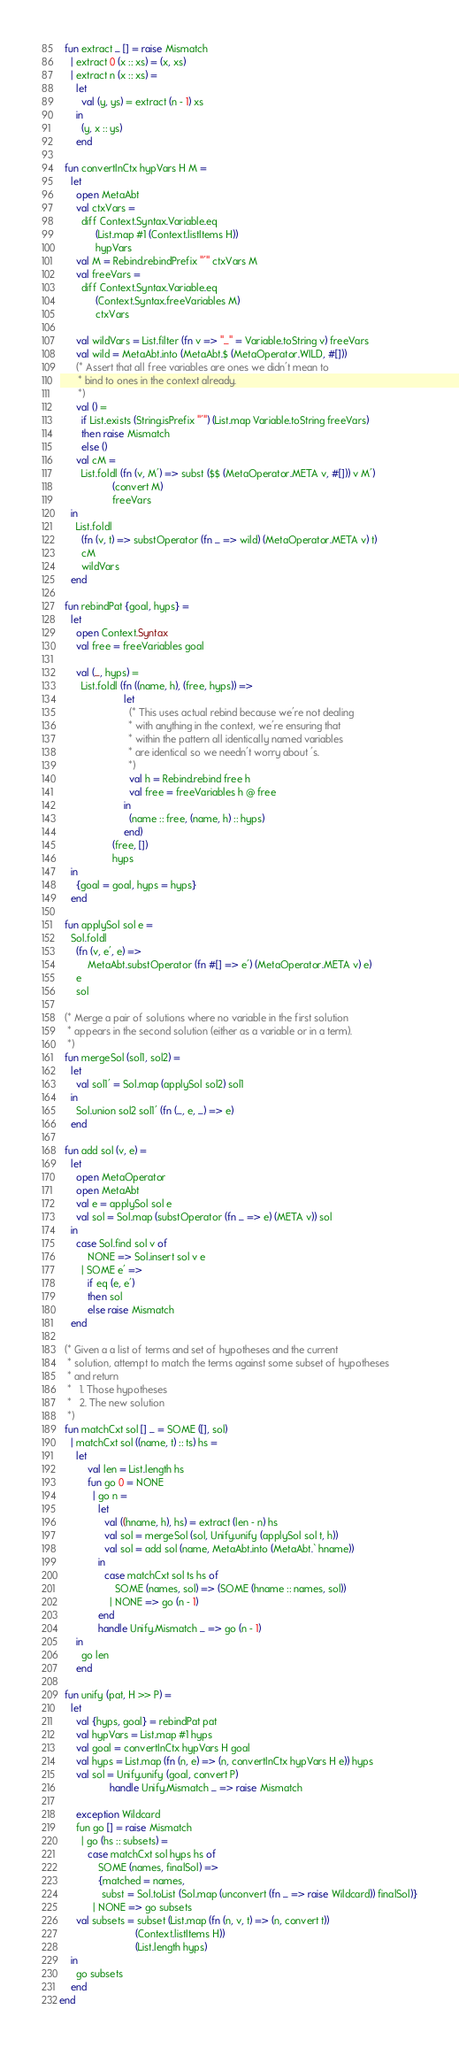<code> <loc_0><loc_0><loc_500><loc_500><_SML_>  fun extract _ [] = raise Mismatch
    | extract 0 (x :: xs) = (x, xs)
    | extract n (x :: xs) =
      let
        val (y, ys) = extract (n - 1) xs
      in
        (y, x :: ys)
      end

  fun convertInCtx hypVars H M =
    let
      open MetaAbt
      val ctxVars =
        diff Context.Syntax.Variable.eq
             (List.map #1 (Context.listItems H))
             hypVars
      val M = Rebind.rebindPrefix "'" ctxVars M
      val freeVars =
        diff Context.Syntax.Variable.eq
             (Context.Syntax.freeVariables M)
             ctxVars

      val wildVars = List.filter (fn v => "_" = Variable.toString v) freeVars
      val wild = MetaAbt.into (MetaAbt.$ (MetaOperator.WILD, #[]))
      (* Assert that all free variables are ones we didn't mean to
       * bind to ones in the context already.
       *)
      val () =
        if List.exists (String.isPrefix "'") (List.map Variable.toString freeVars)
        then raise Mismatch
        else ()
      val cM =
        List.foldl (fn (v, M') => subst ($$ (MetaOperator.META v, #[])) v M')
                   (convert M)
                   freeVars
    in
      List.foldl
        (fn (v, t) => substOperator (fn _ => wild) (MetaOperator.META v) t)
        cM
        wildVars
    end

  fun rebindPat {goal, hyps} =
    let
      open Context.Syntax
      val free = freeVariables goal

      val (_, hyps) =
        List.foldl (fn ((name, h), (free, hyps)) =>
                       let
                         (* This uses actual rebind because we're not dealing
                          * with anything in the context, we're ensuring that
                          * within the pattern all identically named variables
                          * are identical so we needn't worry about 's.
                          *)
                         val h = Rebind.rebind free h
                         val free = freeVariables h @ free
                       in
                         (name :: free, (name, h) :: hyps)
                       end)
                   (free, [])
                   hyps
    in
      {goal = goal, hyps = hyps}
    end

  fun applySol sol e =
    Sol.foldl
      (fn (v, e', e) =>
          MetaAbt.substOperator (fn #[] => e') (MetaOperator.META v) e)
      e
      sol

  (* Merge a pair of solutions where no variable in the first solution
   * appears in the second solution (either as a variable or in a term).
   *)
  fun mergeSol (sol1, sol2) =
    let
      val sol1' = Sol.map (applySol sol2) sol1
    in
      Sol.union sol2 sol1' (fn (_, e, _) => e)
    end

  fun add sol (v, e) =
    let
      open MetaOperator
      open MetaAbt
      val e = applySol sol e
      val sol = Sol.map (substOperator (fn _ => e) (META v)) sol
    in
      case Sol.find sol v of
          NONE => Sol.insert sol v e
        | SOME e' =>
          if eq (e, e')
          then sol
          else raise Mismatch
    end

  (* Given a a list of terms and set of hypotheses and the current
   * solution, attempt to match the terms against some subset of hypotheses
   * and return
   *   1. Those hypotheses
   *   2. The new solution
   *)
  fun matchCxt sol [] _ = SOME ([], sol)
    | matchCxt sol ((name, t) :: ts) hs =
      let
          val len = List.length hs
          fun go 0 = NONE
            | go n =
              let
                val ((hname, h), hs) = extract (len - n) hs
                val sol = mergeSol (sol, Unify.unify (applySol sol t, h))
                val sol = add sol (name, MetaAbt.into (MetaAbt.` hname))
              in
                case matchCxt sol ts hs of
                    SOME (names, sol) => (SOME (hname :: names, sol))
                  | NONE => go (n - 1)
              end
              handle Unify.Mismatch _ => go (n - 1)
      in
        go len
      end

  fun unify (pat, H >> P) =
    let
      val {hyps, goal} = rebindPat pat
      val hypVars = List.map #1 hyps
      val goal = convertInCtx hypVars H goal
      val hyps = List.map (fn (n, e) => (n, convertInCtx hypVars H e)) hyps
      val sol = Unify.unify (goal, convert P)
                  handle Unify.Mismatch _ => raise Mismatch

      exception Wildcard
      fun go [] = raise Mismatch
        | go (hs :: subsets) =
          case matchCxt sol hyps hs of
              SOME (names, finalSol) =>
              {matched = names,
               subst = Sol.toList (Sol.map (unconvert (fn _ => raise Wildcard)) finalSol)}
            | NONE => go subsets
      val subsets = subset (List.map (fn (n, v, t) => (n, convert t))
                           (Context.listItems H))
                           (List.length hyps)
    in
      go subsets
    end
end
</code> 